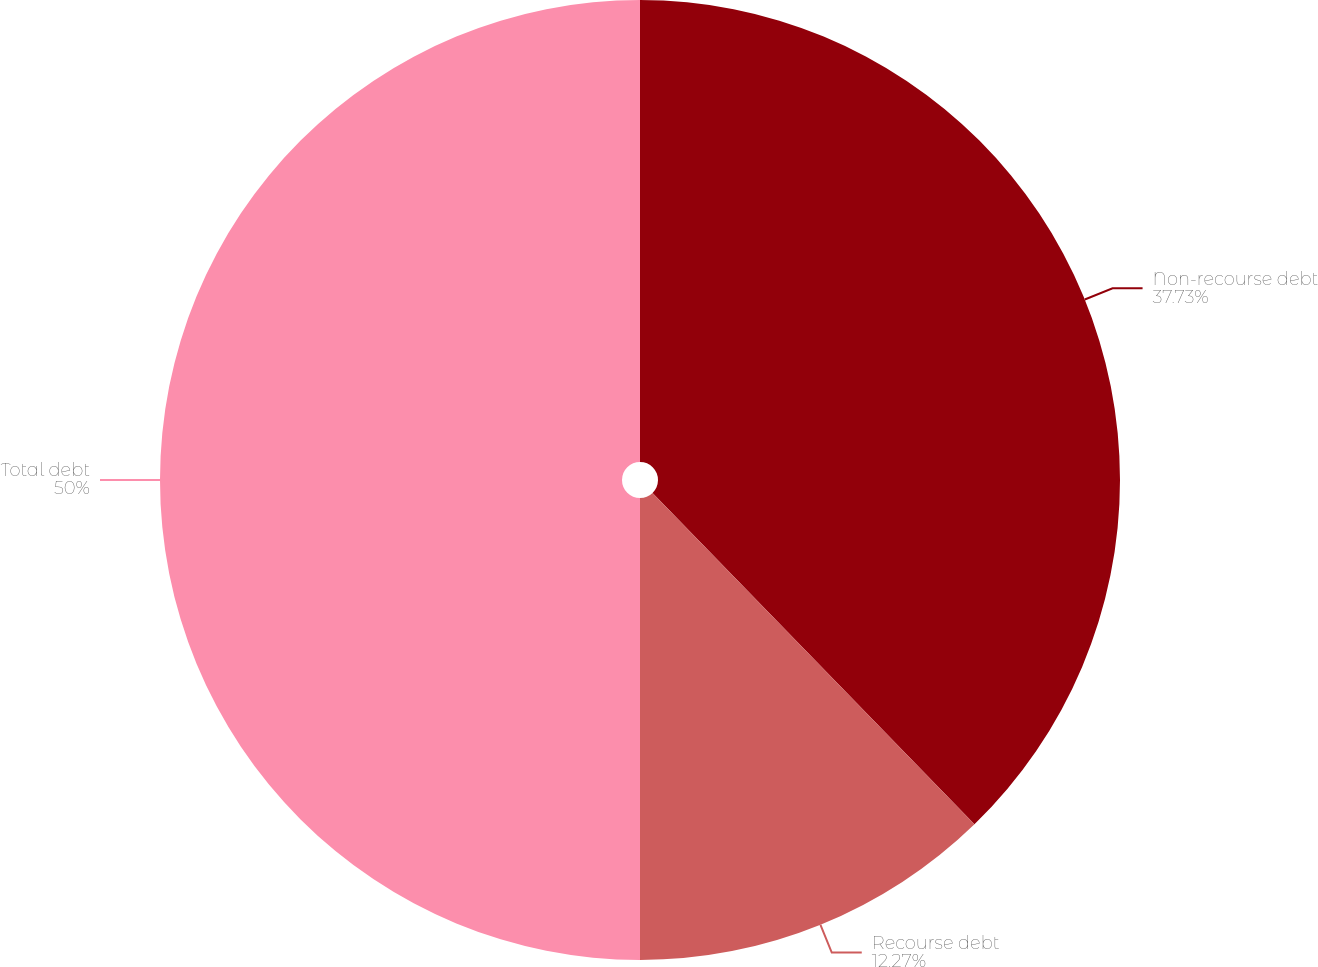<chart> <loc_0><loc_0><loc_500><loc_500><pie_chart><fcel>Non-recourse debt<fcel>Recourse debt<fcel>Total debt<nl><fcel>37.73%<fcel>12.27%<fcel>50.0%<nl></chart> 